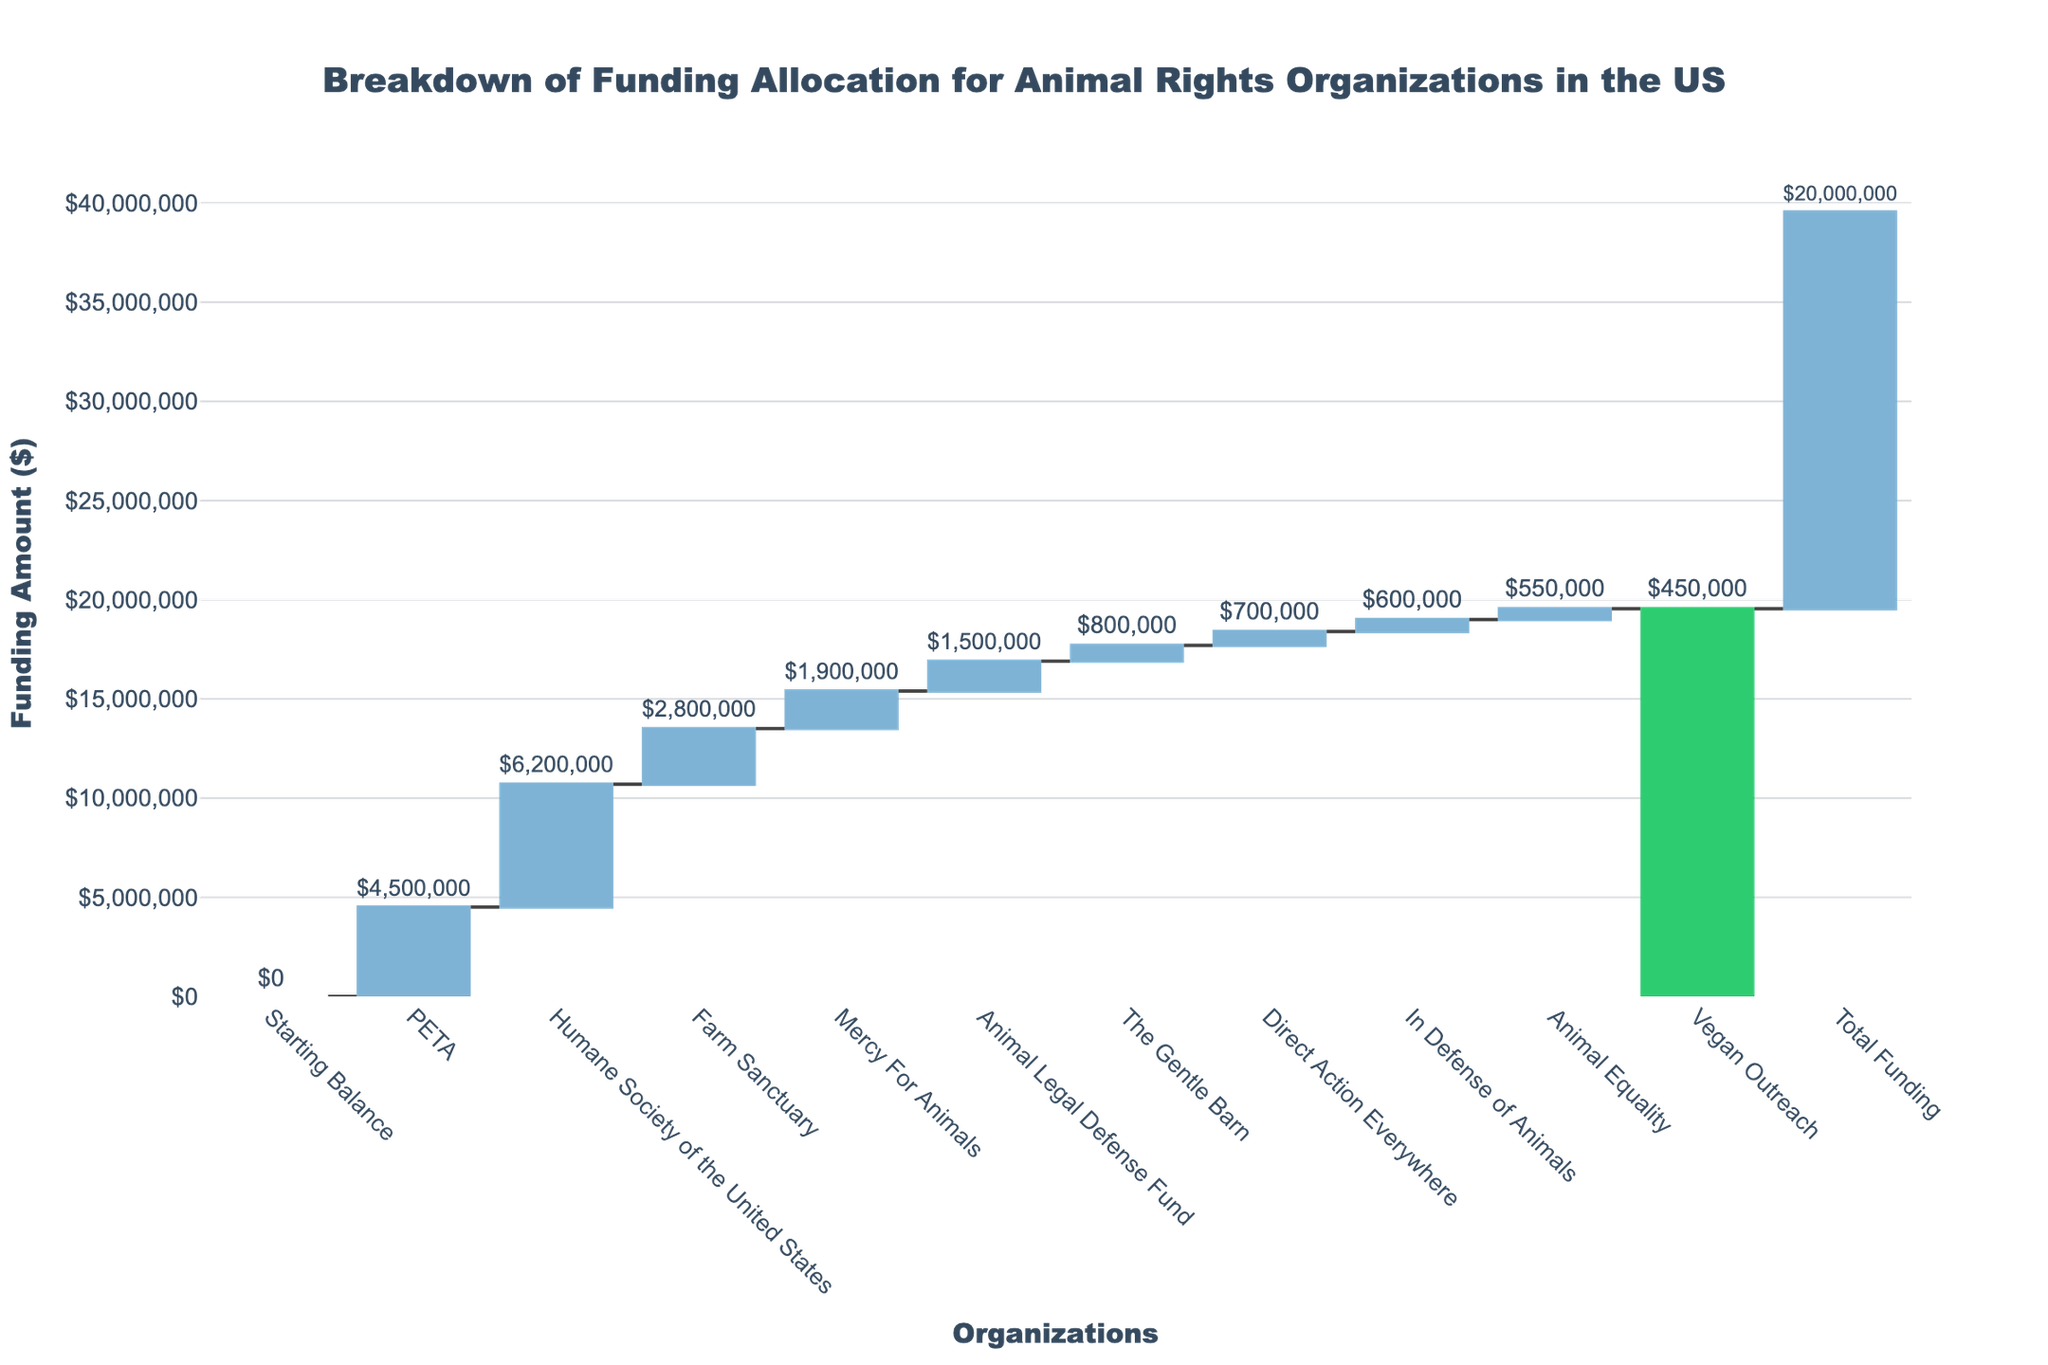What's the title of the chart? The title of the chart is found at the top center of the figure and it reads "Breakdown of Funding Allocation for Animal Rights Organizations in the US".
Answer: Breakdown of Funding Allocation for Animal Rights Organizations in the US Which organization received the highest amount of funding? To find which organization received the highest amount of funding, we look at the vertical bars and identify the one with the tallest height. The Humane Society of the United States received the highest amount.
Answer: Humane Society of the United States What's the total funding amount displayed in the chart? The total funding amount is displayed at the end of the waterfall chart with a green bar, which sums the contributions of all listed organizations.
Answer: $20,000,000 How much funding did PETA receive compared to Direct Action Everywhere? To compare the funding received, look at the individual values at the top of the bars for PETA and Direct Action Everywhere. PETA received $4,500,000 while Direct Action Everywhere received $700,000. Subtract 700,000 from 4,500,000 to get 3,800,000.
Answer: $4,500,000 compared to $700,000 ($3,800,000 more) Which organization received the least funding? Identify the organization with the shortest bar on the chart. Direct Action Everywhere received the least funding among the listed organizations.
Answer: Direct Action Everywhere What is the sum of the funding received by Farm Sanctuary and Mercy For Animals? Farm Sanctuary and Mercy For Animals received $2,800,000 and $1,900,000 respectively. Adding these amounts gives 2,800,000 + 1,900,000 = 4,700,000.
Answer: $4,700,000 What is the average funding amount received by all listed organizations (excluding total funding)? Add the funding amounts for all organizations and then divide by the number of organizations (10). The calculation is: (4,500,000 + 6,200,000 + 2,800,000 + 1,900,000 + 1,500,000 + 800,000 + 700,000 + 600,000 + 550,000 + 450,000) / 10 = 20,000,000 / 10.
Answer: $2,000,000 How does the funding for Vegan Outreach compare to In Defense of Animals? Compare the respective amounts displayed on the chart for Vegan Outreach ($450,000) and In Defense of Animals ($600,000). Vegan Outreach received $150,000 less than In Defense of Animals.
Answer: $150,000 less What percentage of the total funding is allocated to the top three funded organizations? Identify the top three funded organizations: Humane Society of the United States ($6,200,000), PETA ($4,500,000), and Farm Sanctuary ($2,800,000). Sum these amounts: 6,200,000 + 4,500,000 + 2,800,000 = 13,500,000. Calculate the percentage: (13,500,000 / 20,000,000) * 100 = 67.5%.
Answer: 67.5% What is the difference in funding between Animal Legal Defense Fund and Animal Equality? Calculate the difference between the funding amounts for Animal Legal Defense Fund ($1,500,000) and Animal Equality ($550,000). Subtract 550,000 from 1,500,000 to get 950,000.
Answer: $950,000 